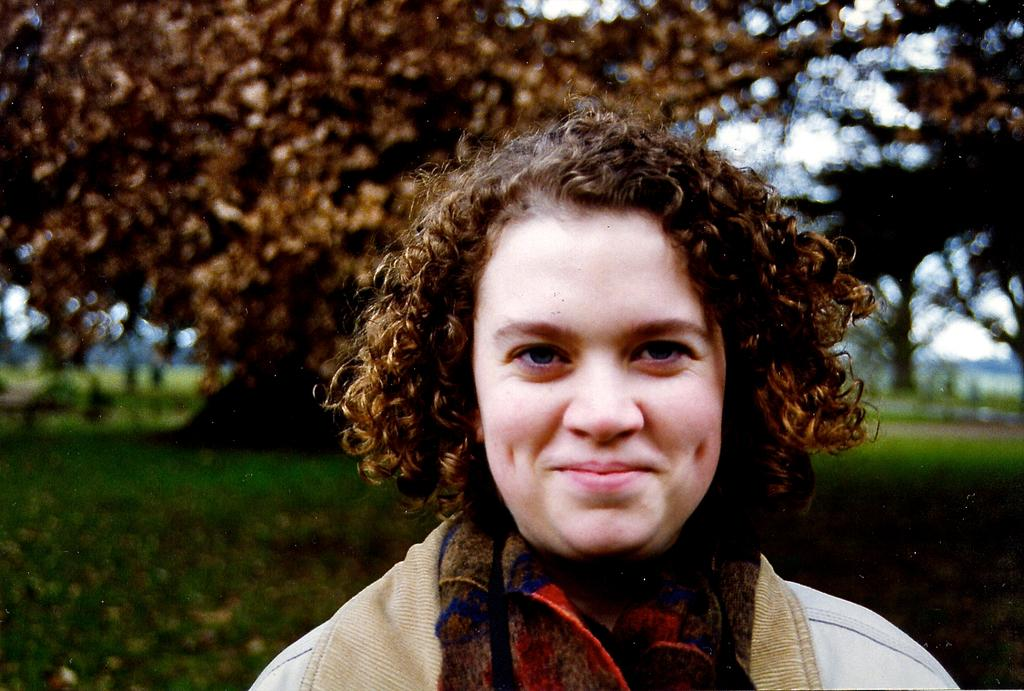Who is present in the image? There is a woman in the image. What is the woman wearing? The woman is wearing a white dress and a shrug. What can be seen in the background of the image? There are trees in the background of the image. What type of cork can be seen in the woman's hair in the image? There is no cork present in the woman's hair or in the image. 